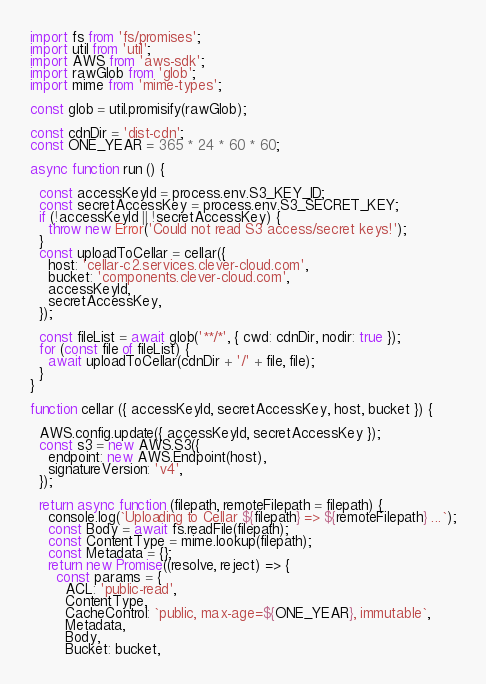<code> <loc_0><loc_0><loc_500><loc_500><_JavaScript_>import fs from 'fs/promises';
import util from 'util';
import AWS from 'aws-sdk';
import rawGlob from 'glob';
import mime from 'mime-types';

const glob = util.promisify(rawGlob);

const cdnDir = 'dist-cdn';
const ONE_YEAR = 365 * 24 * 60 * 60;

async function run () {

  const accessKeyId = process.env.S3_KEY_ID;
  const secretAccessKey = process.env.S3_SECRET_KEY;
  if (!accessKeyId || !secretAccessKey) {
    throw new Error('Could not read S3 access/secret keys!');
  }
  const uploadToCellar = cellar({
    host: 'cellar-c2.services.clever-cloud.com',
    bucket: 'components.clever-cloud.com',
    accessKeyId,
    secretAccessKey,
  });

  const fileList = await glob('**/*', { cwd: cdnDir, nodir: true });
  for (const file of fileList) {
    await uploadToCellar(cdnDir + '/' + file, file);
  }
}

function cellar ({ accessKeyId, secretAccessKey, host, bucket }) {

  AWS.config.update({ accessKeyId, secretAccessKey });
  const s3 = new AWS.S3({
    endpoint: new AWS.Endpoint(host),
    signatureVersion: 'v4',
  });

  return async function (filepath, remoteFilepath = filepath) {
    console.log(`Uploading to Cellar ${filepath} => ${remoteFilepath} ...`);
    const Body = await fs.readFile(filepath);
    const ContentType = mime.lookup(filepath);
    const Metadata = {};
    return new Promise((resolve, reject) => {
      const params = {
        ACL: 'public-read',
        ContentType,
        CacheControl: `public, max-age=${ONE_YEAR}, immutable`,
        Metadata,
        Body,
        Bucket: bucket,</code> 